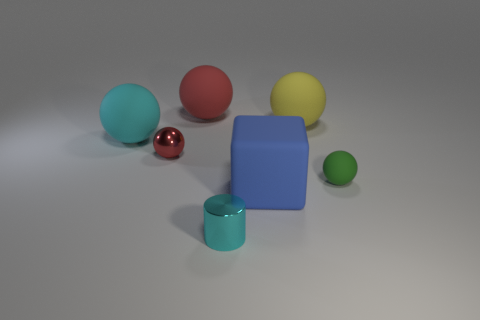What can you infer about the texture of the objects? Most objects have a smooth texture. The blue cube and cylinder have a uniformly matte finish, while the spheres vary, with some having reflective textures. 